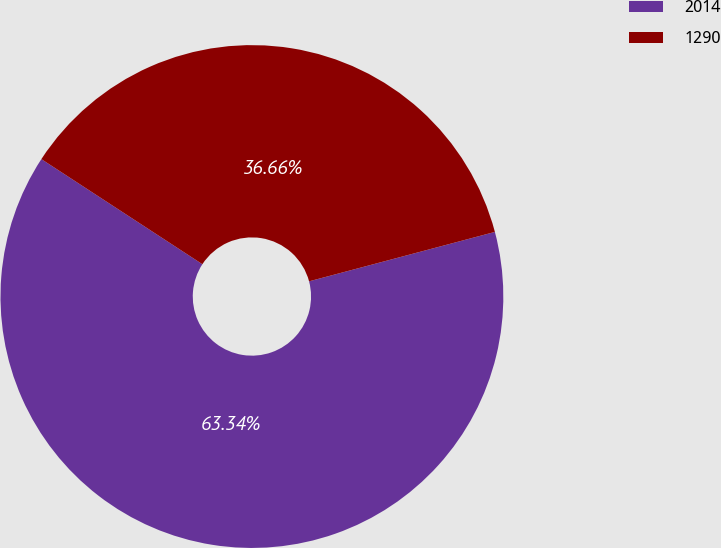<chart> <loc_0><loc_0><loc_500><loc_500><pie_chart><fcel>2014<fcel>1290<nl><fcel>63.34%<fcel>36.66%<nl></chart> 